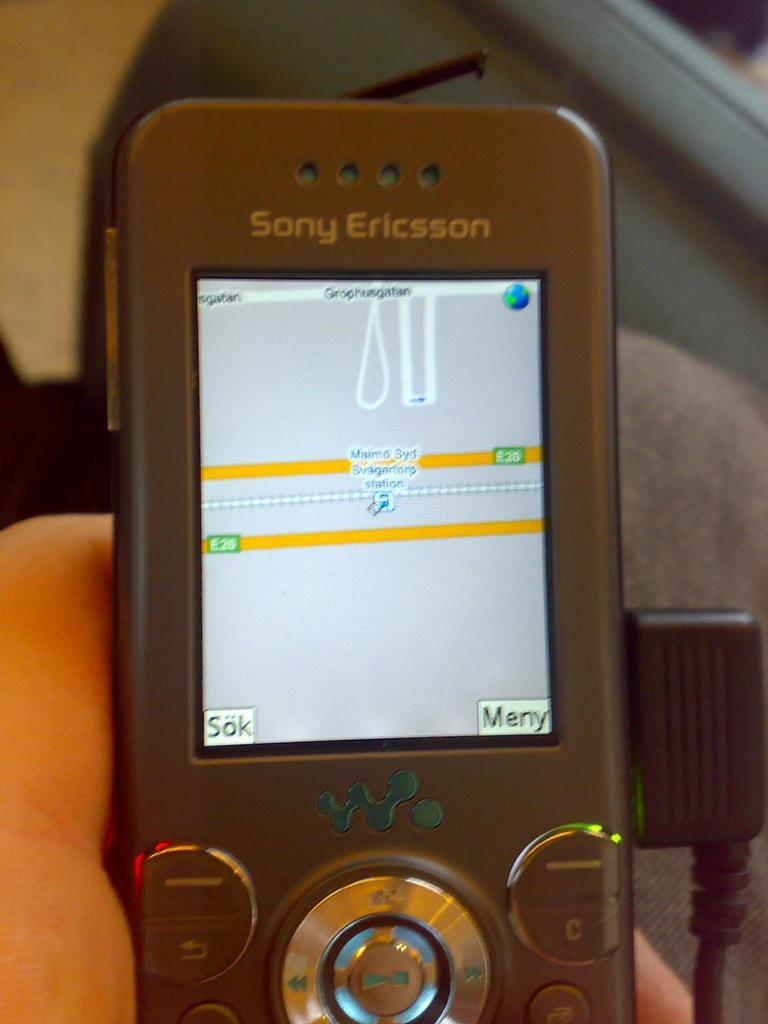<image>
Share a concise interpretation of the image provided. a phone with a sony ericsson name at the top 